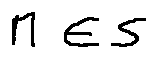<formula> <loc_0><loc_0><loc_500><loc_500>M \in S</formula> 